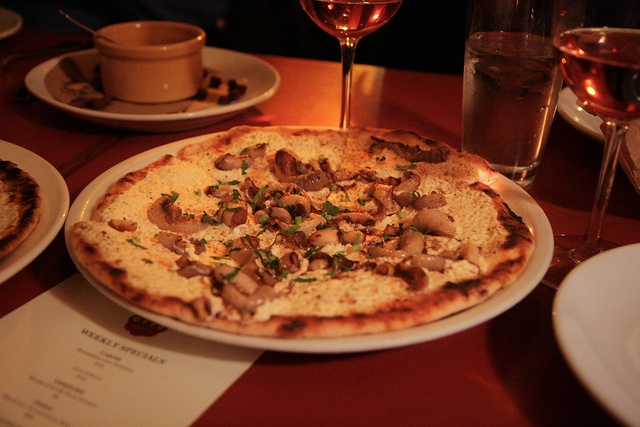Describe the objects in this image and their specific colors. I can see dining table in maroon, black, brown, orange, and gray tones, pizza in black, orange, brown, maroon, and red tones, wine glass in black, maroon, and brown tones, cup in black, maroon, and brown tones, and bowl in black, maroon, and brown tones in this image. 